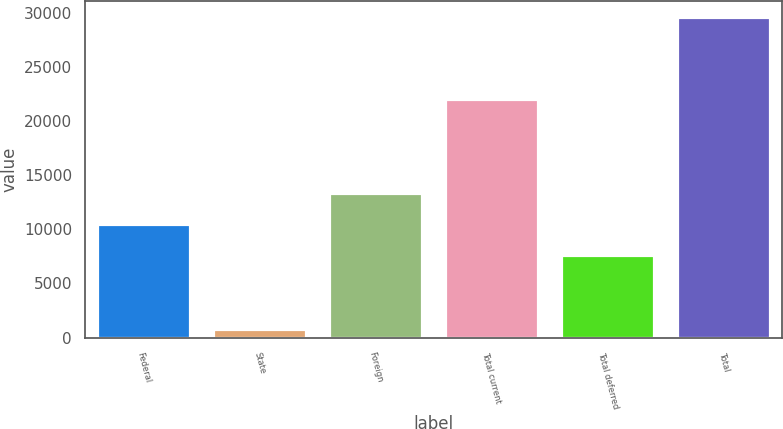<chart> <loc_0><loc_0><loc_500><loc_500><bar_chart><fcel>Federal<fcel>State<fcel>Foreign<fcel>Total current<fcel>Total deferred<fcel>Total<nl><fcel>10479.4<fcel>808<fcel>13358.8<fcel>22002<fcel>7600<fcel>29602<nl></chart> 